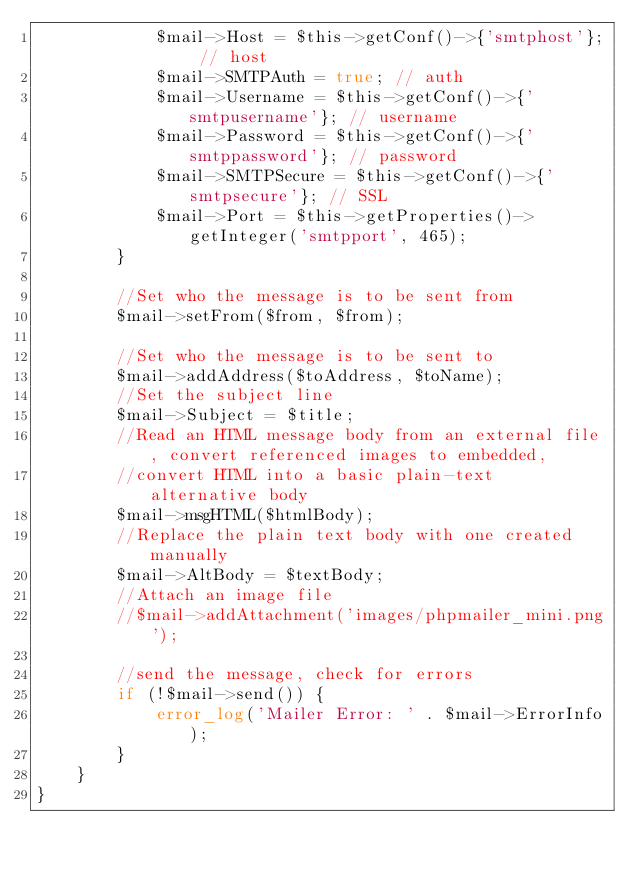Convert code to text. <code><loc_0><loc_0><loc_500><loc_500><_PHP_>            $mail->Host = $this->getConf()->{'smtphost'}; // host
            $mail->SMTPAuth = true; // auth
            $mail->Username = $this->getConf()->{'smtpusername'}; // username
            $mail->Password = $this->getConf()->{'smtppassword'}; // password
            $mail->SMTPSecure = $this->getConf()->{'smtpsecure'}; // SSL
            $mail->Port = $this->getProperties()->getInteger('smtpport', 465);
        }

        //Set who the message is to be sent from
        $mail->setFrom($from, $from);

        //Set who the message is to be sent to
        $mail->addAddress($toAddress, $toName);
        //Set the subject line
        $mail->Subject = $title;
        //Read an HTML message body from an external file, convert referenced images to embedded,
        //convert HTML into a basic plain-text alternative body
        $mail->msgHTML($htmlBody);
        //Replace the plain text body with one created manually
        $mail->AltBody = $textBody;
        //Attach an image file
        //$mail->addAttachment('images/phpmailer_mini.png');

        //send the message, check for errors
        if (!$mail->send()) {
            error_log('Mailer Error: ' . $mail->ErrorInfo);
        }
    }
}
</code> 